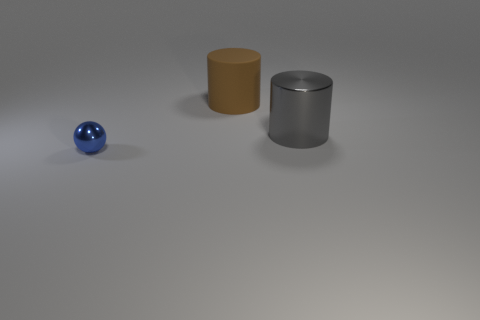Add 2 large purple blocks. How many objects exist? 5 Subtract all cylinders. How many objects are left? 1 Subtract all large cyan metallic cubes. Subtract all cylinders. How many objects are left? 1 Add 2 large cylinders. How many large cylinders are left? 4 Add 2 large brown cylinders. How many large brown cylinders exist? 3 Subtract 0 brown blocks. How many objects are left? 3 